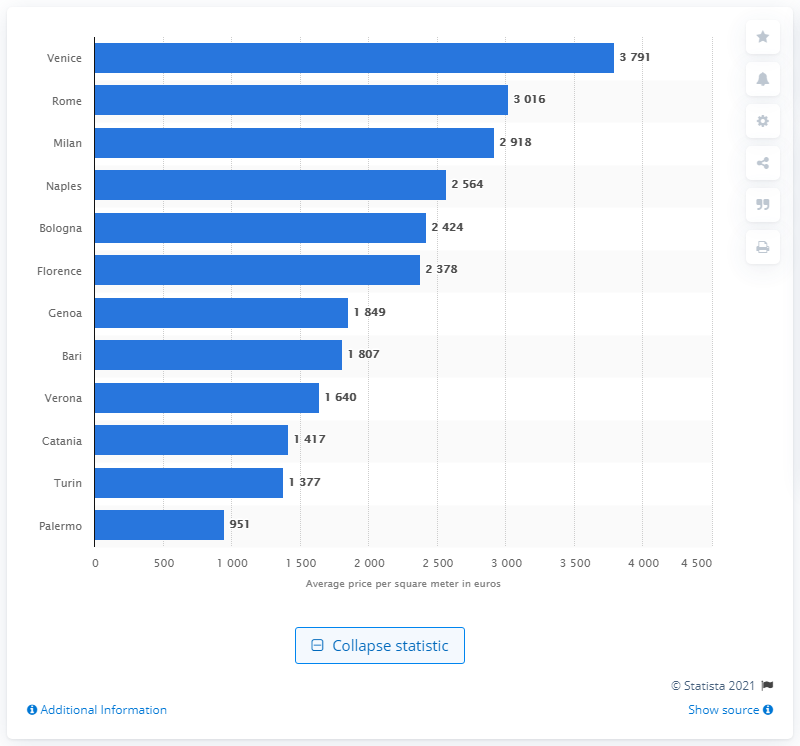Specify some key components in this picture. According to a recent report, Venice was the most expensive city in Italy to purchase office space in 2019. Rome is the second most expensive city in Italy to purchase office space. 